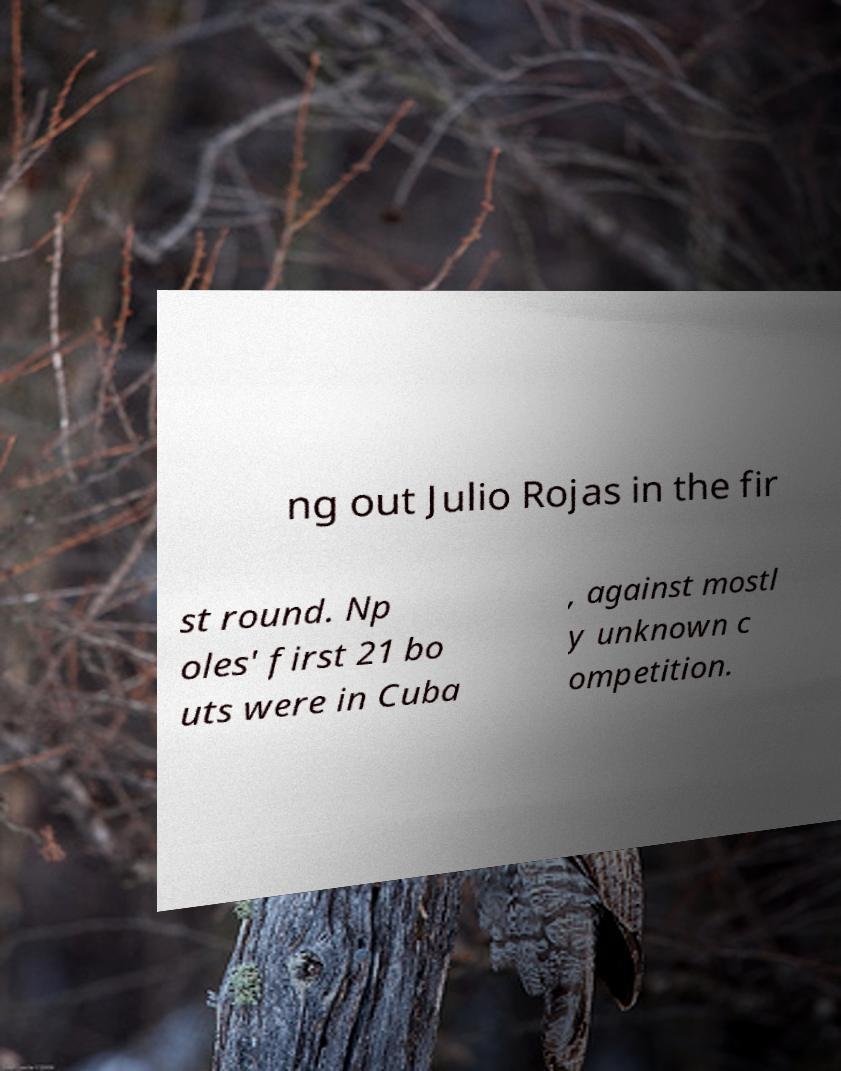I need the written content from this picture converted into text. Can you do that? ng out Julio Rojas in the fir st round. Np oles' first 21 bo uts were in Cuba , against mostl y unknown c ompetition. 